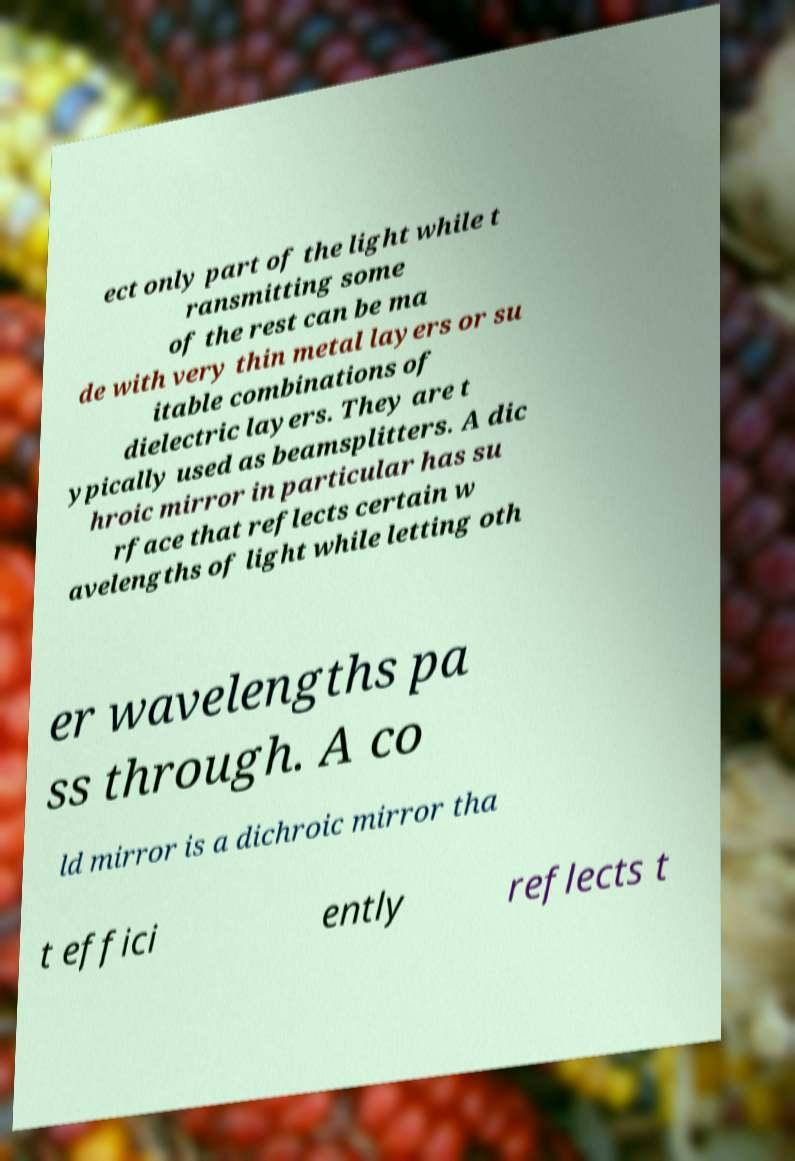Can you read and provide the text displayed in the image?This photo seems to have some interesting text. Can you extract and type it out for me? ect only part of the light while t ransmitting some of the rest can be ma de with very thin metal layers or su itable combinations of dielectric layers. They are t ypically used as beamsplitters. A dic hroic mirror in particular has su rface that reflects certain w avelengths of light while letting oth er wavelengths pa ss through. A co ld mirror is a dichroic mirror tha t effici ently reflects t 